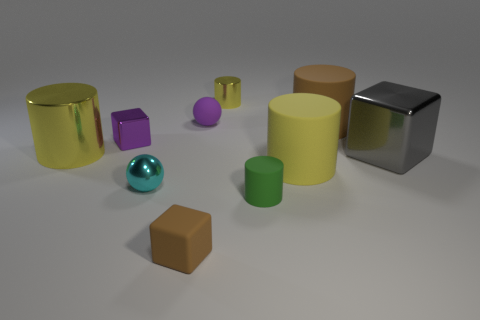What is the material of the sphere that is the same color as the small shiny block?
Your answer should be very brief. Rubber. Do the brown matte cylinder and the green cylinder have the same size?
Offer a very short reply. No. There is a metallic cube that is to the left of the small yellow object; are there any rubber objects right of it?
Provide a succinct answer. Yes. There is a object that is the same color as the tiny rubber ball; what size is it?
Make the answer very short. Small. There is a big brown thing that is to the right of the large metallic cylinder; what shape is it?
Your response must be concise. Cylinder. There is a brown rubber object right of the small cylinder that is to the left of the tiny green cylinder; how many big gray objects are to the left of it?
Make the answer very short. 0. There is a brown cylinder; is it the same size as the metal block that is behind the large gray cube?
Provide a short and direct response. No. There is a yellow metallic thing that is in front of the sphere to the right of the rubber cube; how big is it?
Ensure brevity in your answer.  Large. How many brown objects are the same material as the green cylinder?
Your answer should be very brief. 2. Are any brown metallic cubes visible?
Ensure brevity in your answer.  No. 